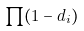Convert formula to latex. <formula><loc_0><loc_0><loc_500><loc_500>\prod ( 1 - d _ { i } )</formula> 